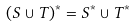<formula> <loc_0><loc_0><loc_500><loc_500>( S \cup T ) ^ { * } = S ^ { * } \cup T ^ { * }</formula> 